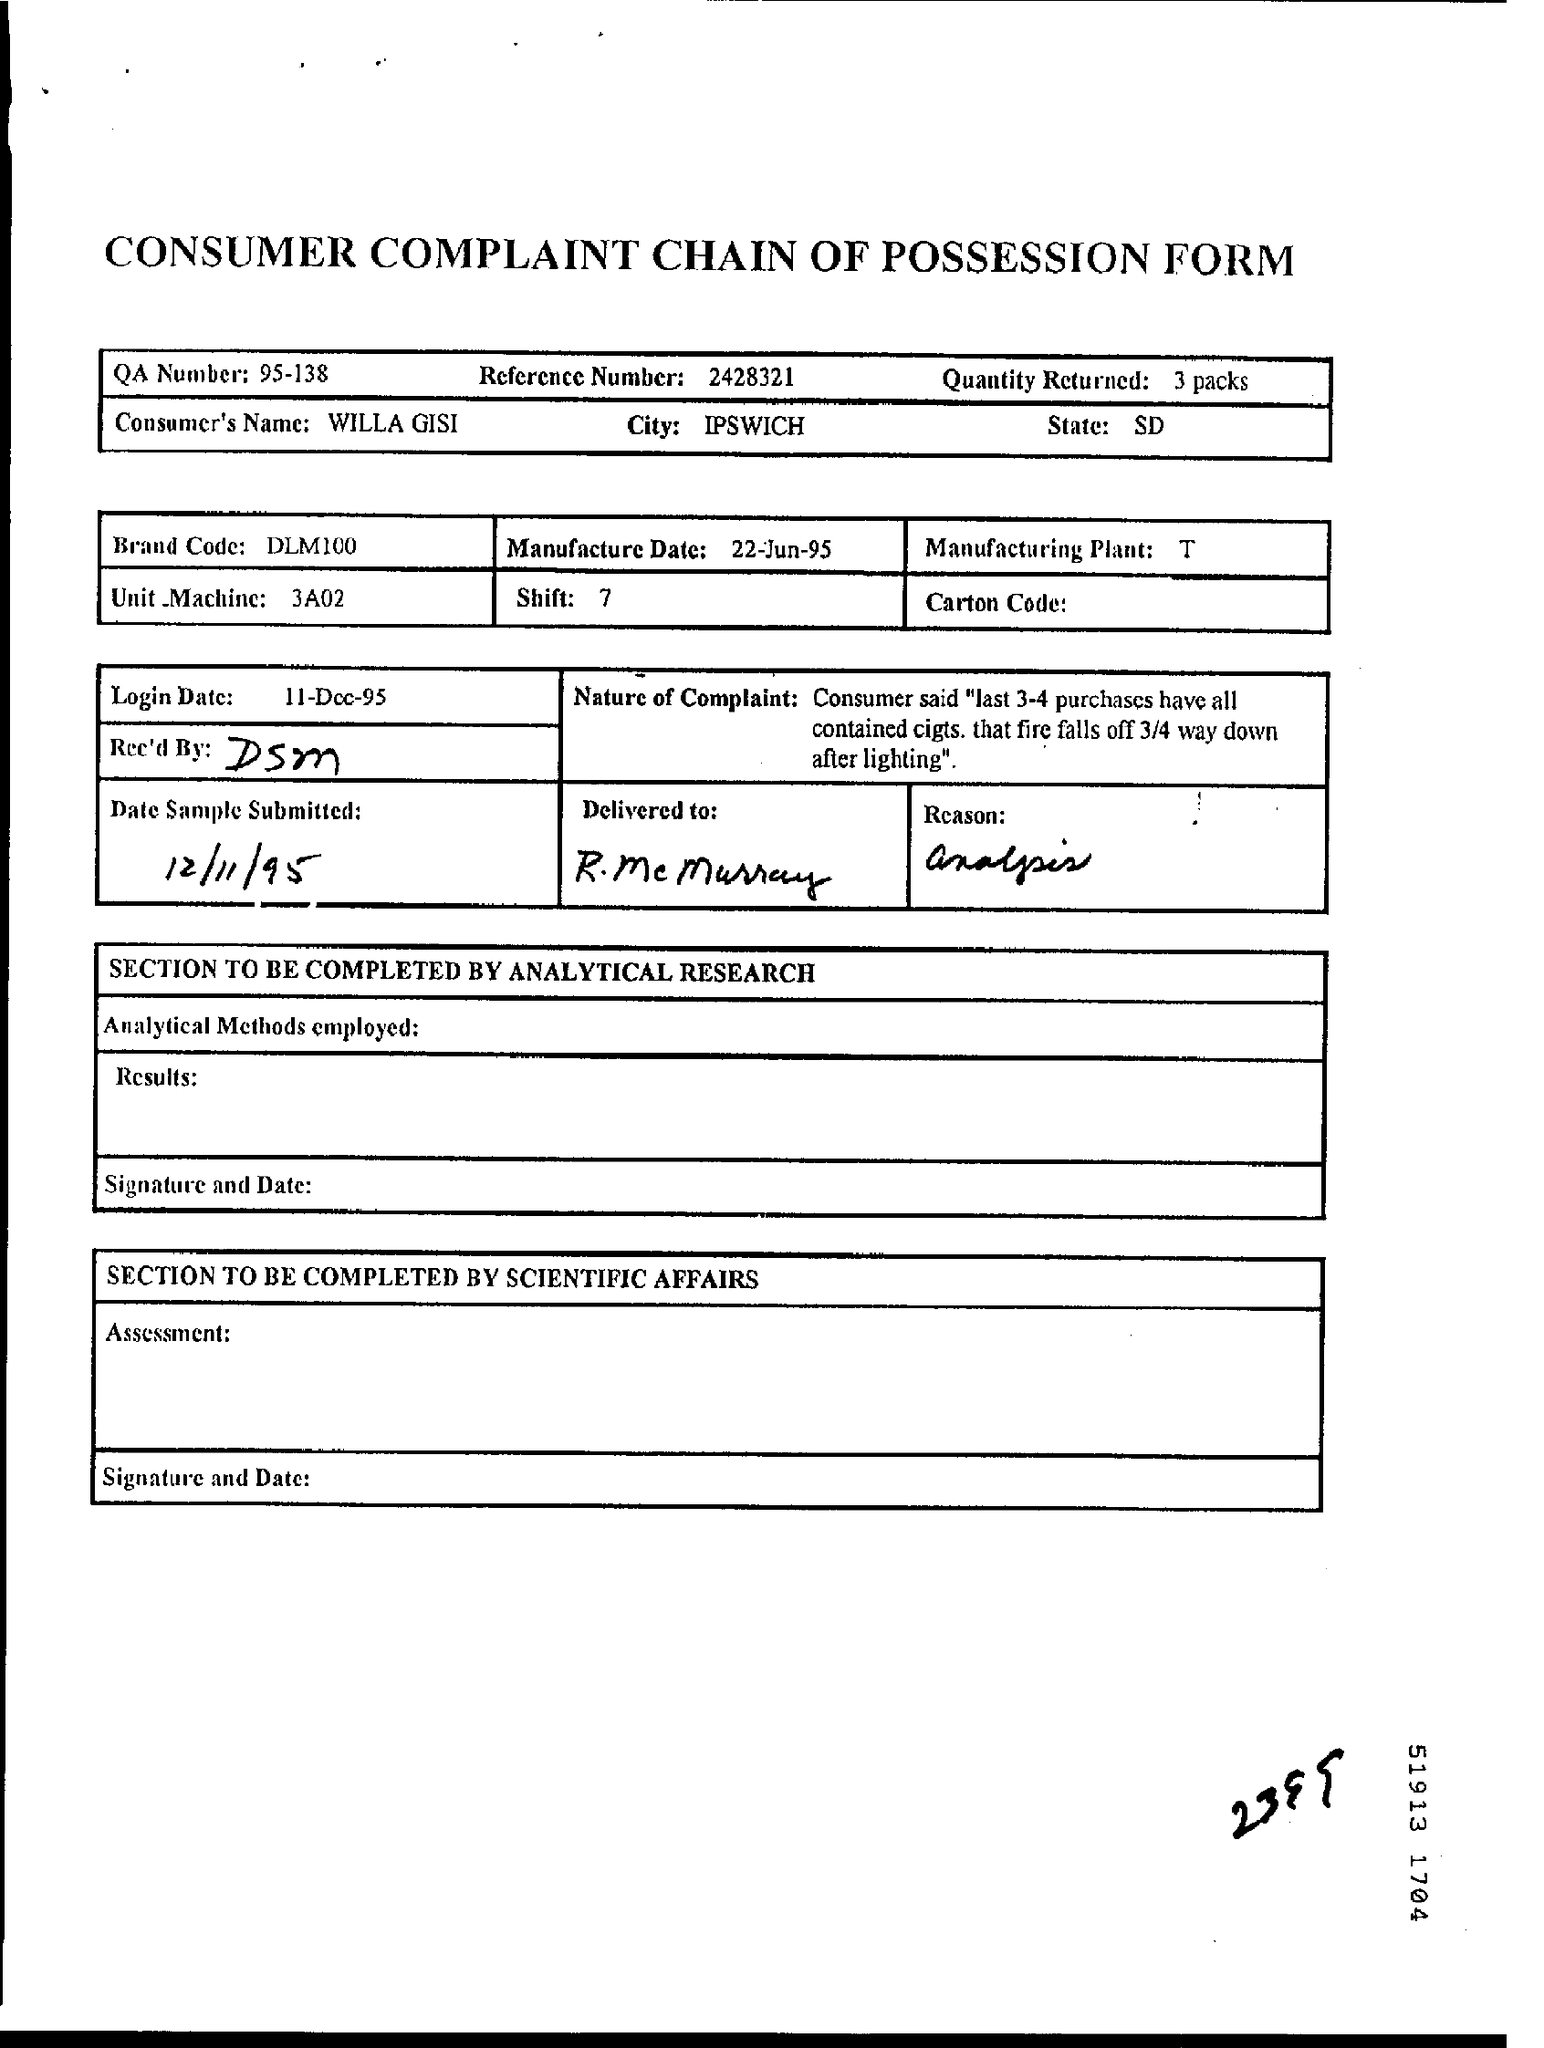What is the consumer's name ?
Offer a terse response. Willa Gisi. What is the qa number ?
Offer a very short reply. 95-138. What is the reference number ?
Your answer should be very brief. 2428321. How much quantity is returned ?
Your response must be concise. 3 packs. What is the name of the city ?
Your response must be concise. IPSWICH. What is the name of the state ?
Keep it short and to the point. SD. What is the manufacture date ?
Provide a short and direct response. 22-jun-95. What is the login date?
Provide a succinct answer. 11-Dec-95. What is the date sample submitted ?
Ensure brevity in your answer.  12/11/95. What is the brand code ?
Your answer should be compact. DLM100. 